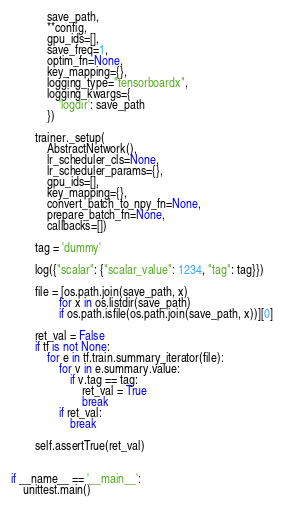Convert code to text. <code><loc_0><loc_0><loc_500><loc_500><_Python_>            save_path,
            **config,
            gpu_ids=[],
            save_freq=1,
            optim_fn=None,
            key_mapping={},
            logging_type="tensorboardx",
            logging_kwargs={
                'logdir': save_path
            })

        trainer._setup(
            AbstractNetwork(),
            lr_scheduler_cls=None,
            lr_scheduler_params={},
            gpu_ids=[],
            key_mapping={},
            convert_batch_to_npy_fn=None,
            prepare_batch_fn=None,
            callbacks=[])

        tag = 'dummy'

        log({"scalar": {"scalar_value": 1234, "tag": tag}})

        file = [os.path.join(save_path, x)
                for x in os.listdir(save_path)
                if os.path.isfile(os.path.join(save_path, x))][0]

        ret_val = False
        if tf is not None:
            for e in tf.train.summary_iterator(file):
                for v in e.summary.value:
                    if v.tag == tag:
                        ret_val = True
                        break
                if ret_val:
                    break

        self.assertTrue(ret_val)


if __name__ == '__main__':
    unittest.main()
</code> 